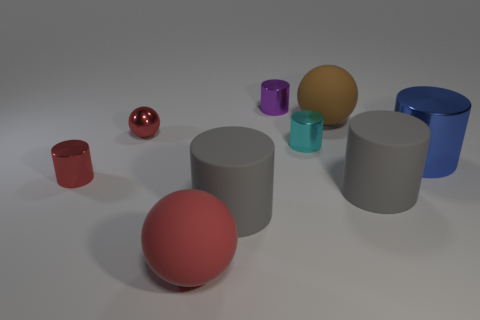There is a tiny cylinder that is the same color as the metal sphere; what is it made of?
Provide a succinct answer. Metal. There is a small metal thing that is the same color as the small sphere; what is its shape?
Your answer should be compact. Cylinder. There is a red sphere that is in front of the red metal thing that is to the right of the small shiny thing that is in front of the blue cylinder; how big is it?
Your answer should be very brief. Large. How many brown objects are balls or large matte cylinders?
Your answer should be very brief. 1. Is the shape of the big gray object to the left of the tiny purple thing the same as  the brown matte object?
Keep it short and to the point. No. Is the number of spheres on the right side of the blue cylinder greater than the number of red rubber spheres?
Provide a short and direct response. No. What number of cylinders have the same size as the red rubber sphere?
Your answer should be very brief. 3. The other sphere that is the same color as the tiny shiny sphere is what size?
Keep it short and to the point. Large. How many objects are purple things or rubber spheres that are behind the large red matte sphere?
Make the answer very short. 2. What is the color of the small thing that is both in front of the red shiny sphere and left of the cyan object?
Offer a very short reply. Red. 